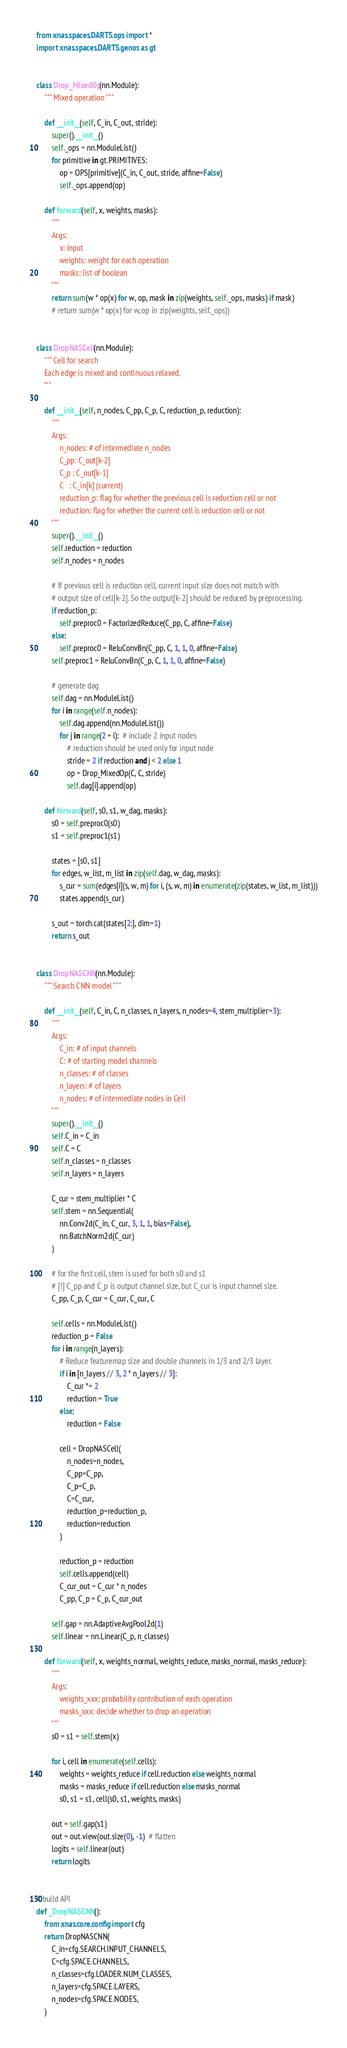<code> <loc_0><loc_0><loc_500><loc_500><_Python_>from xnas.spaces.DARTS.ops import *
import xnas.spaces.DARTS.genos as gt


class Drop_MixedOp(nn.Module):
    """ Mixed operation """

    def __init__(self, C_in, C_out, stride):
        super().__init__()
        self._ops = nn.ModuleList()
        for primitive in gt.PRIMITIVES:
            op = OPS[primitive](C_in, C_out, stride, affine=False)
            self._ops.append(op)

    def forward(self, x, weights, masks):
        """
        Args:
            x: input
            weights: weight for each operation
            masks: list of boolean
        """
        return sum(w * op(x) for w, op, mask in zip(weights, self._ops, masks) if mask)
        # return sum(w * op(x) for w, op in zip(weights, self._ops))


class DropNASCell(nn.Module):
    """ Cell for search
    Each edge is mixed and continuous relaxed.
    """

    def __init__(self, n_nodes, C_pp, C_p, C, reduction_p, reduction):
        """
        Args:
            n_nodes: # of intermediate n_nodes
            C_pp: C_out[k-2]
            C_p : C_out[k-1]
            C   : C_in[k] (current)
            reduction_p: flag for whether the previous cell is reduction cell or not
            reduction: flag for whether the current cell is reduction cell or not
        """
        super().__init__()
        self.reduction = reduction
        self.n_nodes = n_nodes

        # If previous cell is reduction cell, current input size does not match with
        # output size of cell[k-2]. So the output[k-2] should be reduced by preprocessing.
        if reduction_p:
            self.preproc0 = FactorizedReduce(C_pp, C, affine=False)
        else:
            self.preproc0 = ReluConvBn(C_pp, C, 1, 1, 0, affine=False)
        self.preproc1 = ReluConvBn(C_p, C, 1, 1, 0, affine=False)

        # generate dag
        self.dag = nn.ModuleList()
        for i in range(self.n_nodes):
            self.dag.append(nn.ModuleList())
            for j in range(2 + i):  # include 2 input nodes
                # reduction should be used only for input node
                stride = 2 if reduction and j < 2 else 1
                op = Drop_MixedOp(C, C, stride)
                self.dag[i].append(op)

    def forward(self, s0, s1, w_dag, masks):
        s0 = self.preproc0(s0)
        s1 = self.preproc1(s1)

        states = [s0, s1]
        for edges, w_list, m_list in zip(self.dag, w_dag, masks):
            s_cur = sum(edges[i](s, w, m) for i, (s, w, m) in enumerate(zip(states, w_list, m_list)))
            states.append(s_cur)

        s_out = torch.cat(states[2:], dim=1)
        return s_out


class DropNASCNN(nn.Module):
    """ Search CNN model """

    def __init__(self, C_in, C, n_classes, n_layers, n_nodes=4, stem_multiplier=3):
        """
        Args:
            C_in: # of input channels
            C: # of starting model channels
            n_classes: # of classes
            n_layers: # of layers
            n_nodes: # of intermediate nodes in Cell
        """
        super().__init__()
        self.C_in = C_in
        self.C = C
        self.n_classes = n_classes
        self.n_layers = n_layers

        C_cur = stem_multiplier * C
        self.stem = nn.Sequential(
            nn.Conv2d(C_in, C_cur, 3, 1, 1, bias=False),
            nn.BatchNorm2d(C_cur)
        )

        # for the first cell, stem is used for both s0 and s1
        # [!] C_pp and C_p is output channel size, but C_cur is input channel size.
        C_pp, C_p, C_cur = C_cur, C_cur, C

        self.cells = nn.ModuleList()
        reduction_p = False
        for i in range(n_layers):
            # Reduce featuremap size and double channels in 1/3 and 2/3 layer.
            if i in [n_layers // 3, 2 * n_layers // 3]:
                C_cur *= 2
                reduction = True
            else:
                reduction = False

            cell = DropNASCell(
                n_nodes=n_nodes, 
                C_pp=C_pp, 
                C_p=C_p, 
                C=C_cur, 
                reduction_p=reduction_p,
                reduction=reduction
            )

            reduction_p = reduction
            self.cells.append(cell)
            C_cur_out = C_cur * n_nodes
            C_pp, C_p = C_p, C_cur_out

        self.gap = nn.AdaptiveAvgPool2d(1)
        self.linear = nn.Linear(C_p, n_classes)

    def forward(self, x, weights_normal, weights_reduce, masks_normal, masks_reduce):
        """
        Args:
            weights_xxx: probability contribution of each operation
            masks_xxx: decide whether to drop an operation
        """
        s0 = s1 = self.stem(x)

        for i, cell in enumerate(self.cells):
            weights = weights_reduce if cell.reduction else weights_normal
            masks = masks_reduce if cell.reduction else masks_normal
            s0, s1 = s1, cell(s0, s1, weights, masks)

        out = self.gap(s1)
        out = out.view(out.size(0), -1)  # flatten
        logits = self.linear(out)
        return logits


# build API
def _DropNASCNN():
    from xnas.core.config import cfg
    return DropNASCNN(
        C_in=cfg.SEARCH.INPUT_CHANNELS, 
        C=cfg.SPACE.CHANNELS, 
        n_classes=cfg.LOADER.NUM_CLASSES, 
        n_layers=cfg.SPACE.LAYERS,
        n_nodes=cfg.SPACE.NODES,
    )
</code> 